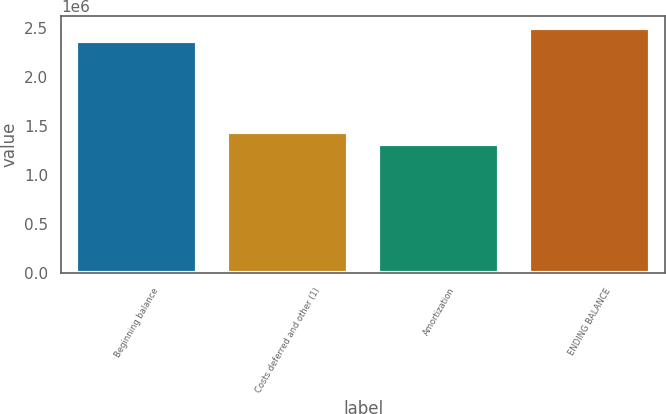<chart> <loc_0><loc_0><loc_500><loc_500><bar_chart><fcel>Beginning balance<fcel>Costs deferred and other (1)<fcel>Amortization<fcel>ENDING BALANCE<nl><fcel>2.36618e+06<fcel>1.44331e+06<fcel>1.31664e+06<fcel>2.49286e+06<nl></chart> 